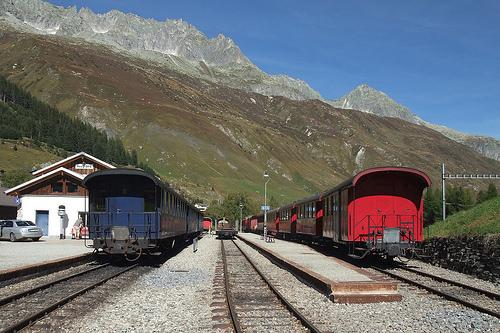What are the most visually dominant components in the image? A red train, a blue train, grey jagged mountains, green pine trees on a hill, and a brown and white building are the most visually dominant components. Using a poetic language style, give a brief description of the scene in the image. Amidst the embrace of majestic grey mountains and verdant pine hills, the red and blue iron steeds patiently await their departure on the time-worn rails. Briefly describe the setting of the image. The scene takes place in an outdoor location featuring trains on tracks, surrounded by nature and a building. Mention the different types of vehicles found in the image. A red train, a blue train, and a silver car are the vehicles present in the image. Give an overview of the landscape and the trains present in the picture. The landscape consists of grey jagged mountains, green pine trees on a hill, and a brown and white building, with a red and a blue train on rusty tracks in the foreground. List the objects in the image along with their colors and correlations. Objects include: red train, blue train, rusty train tracks, rock gravel, silver car, grey mountains, brown and white building, green pine trees on a hill, and blue door. Provide a concise summary of the picture, focusing on the main elements. The picture depicts a red and a blue train on rusty tracks, surrounded by trees, mountains, and a brown and white building. Mention the most prominent objects in the picture along with their colors and relative positions. The image features a red train and a blue train on rusty train tracks, a brown and white building with two roofs, grey jagged mountains, and green pine trees on a hill. Describe the trains and their surroundings in short. A red and a blue train are stationed on rusty tracks with a patch of rock gravel between them, surrounded by trees, mountains, and a brown and white building. Describe the main transportation elements in the image. The main transportation elements include a red train, a blue train, rusty train tracks, and a silver car parked nearby. 